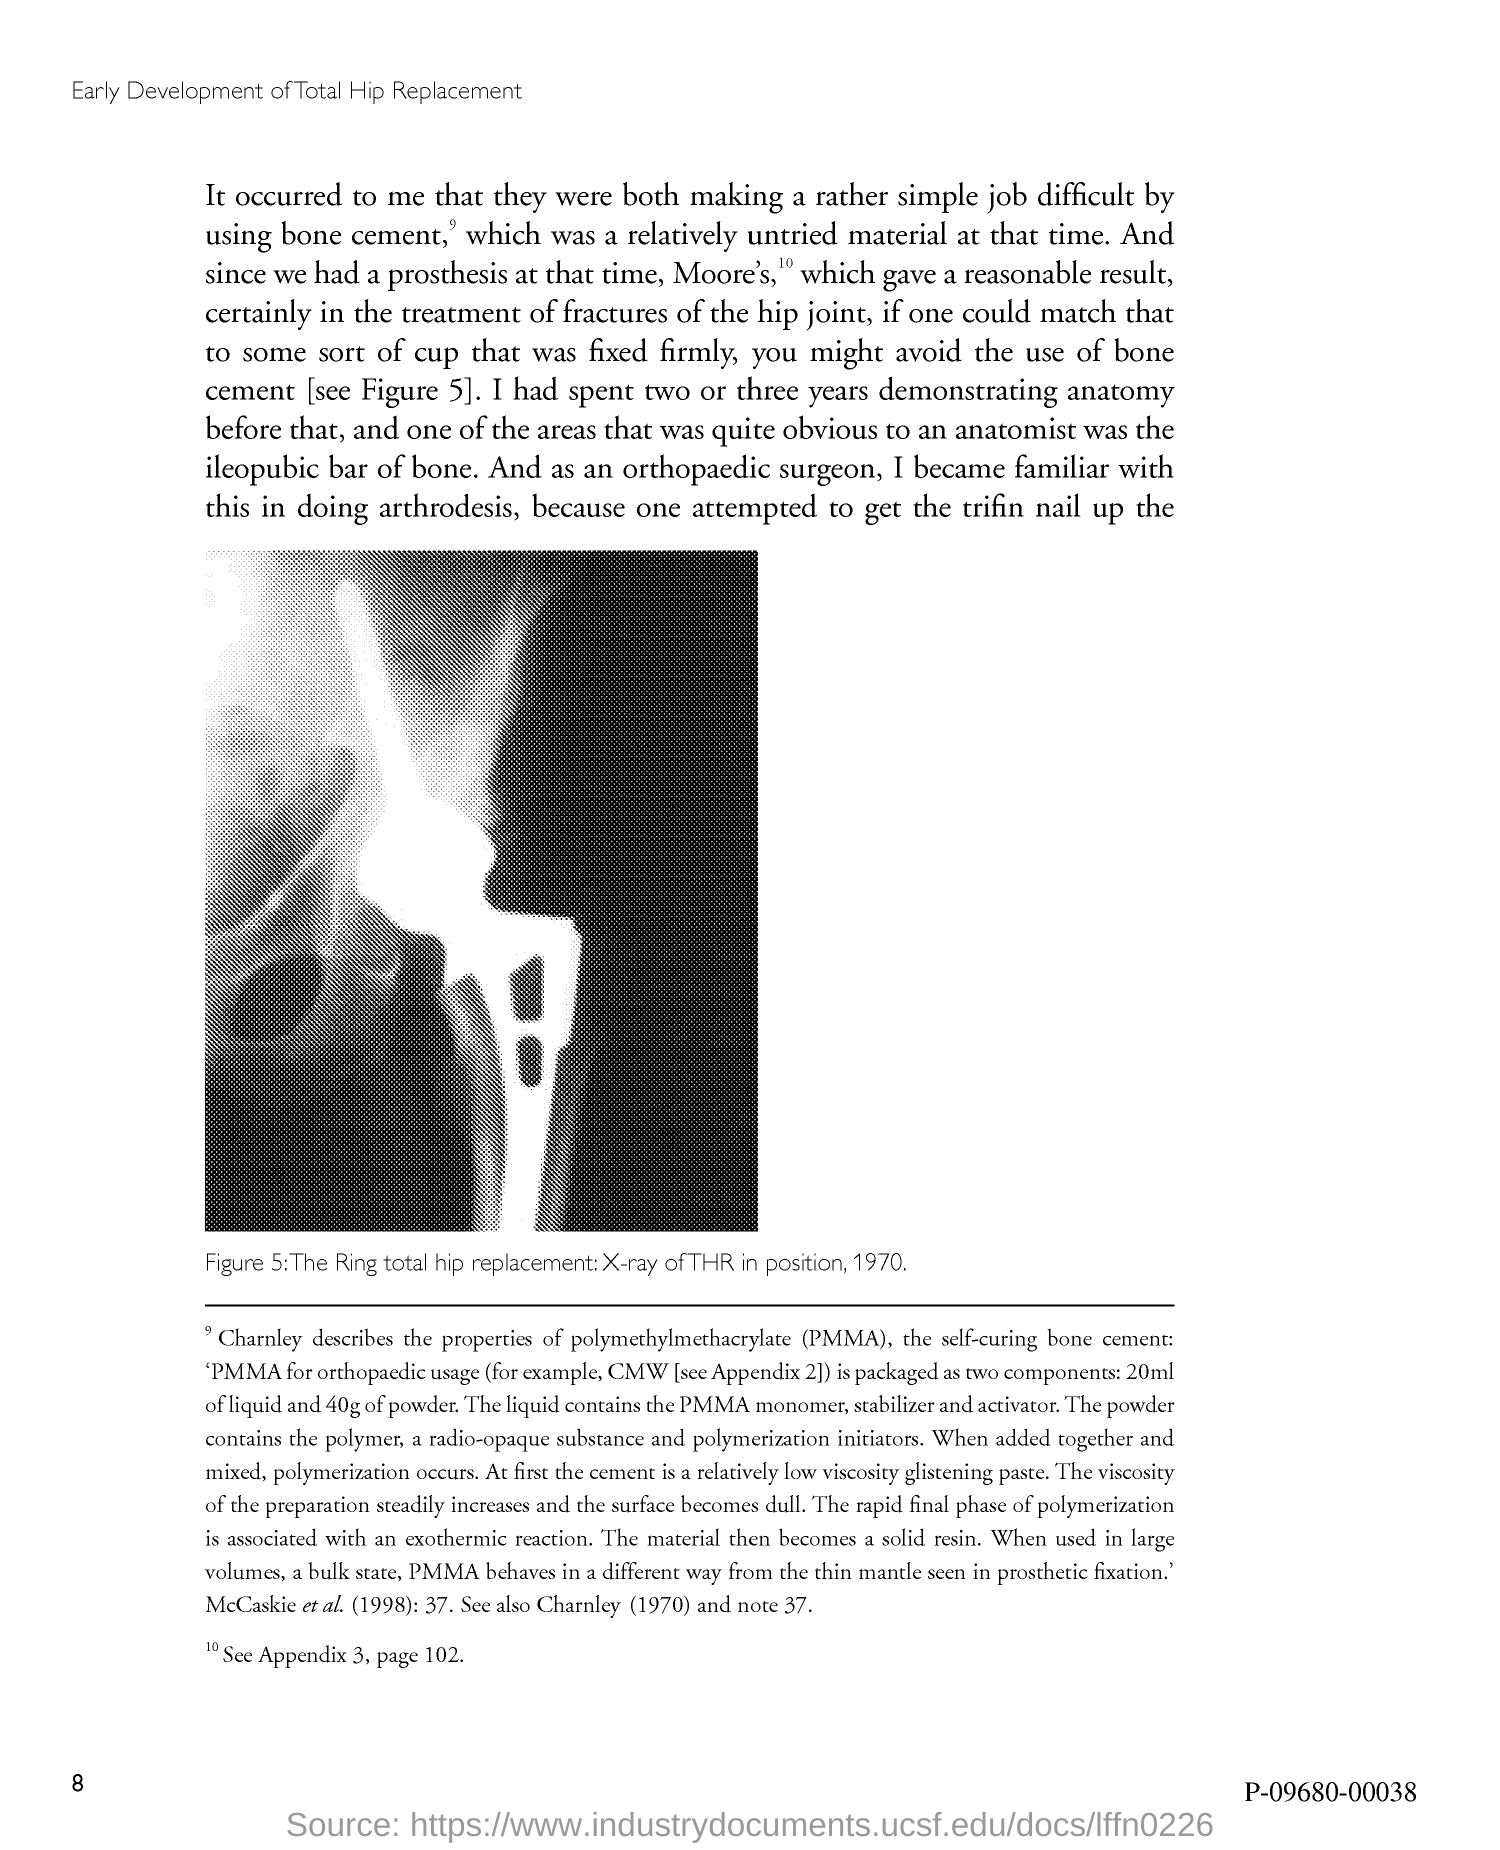What does Figure 5 in this document shows?
Ensure brevity in your answer.  The ring total hip replacement x-ray of thr in position, 1970. What is the fullform of PMMA?
Your answer should be very brief. Polymethylmethacrylate. 